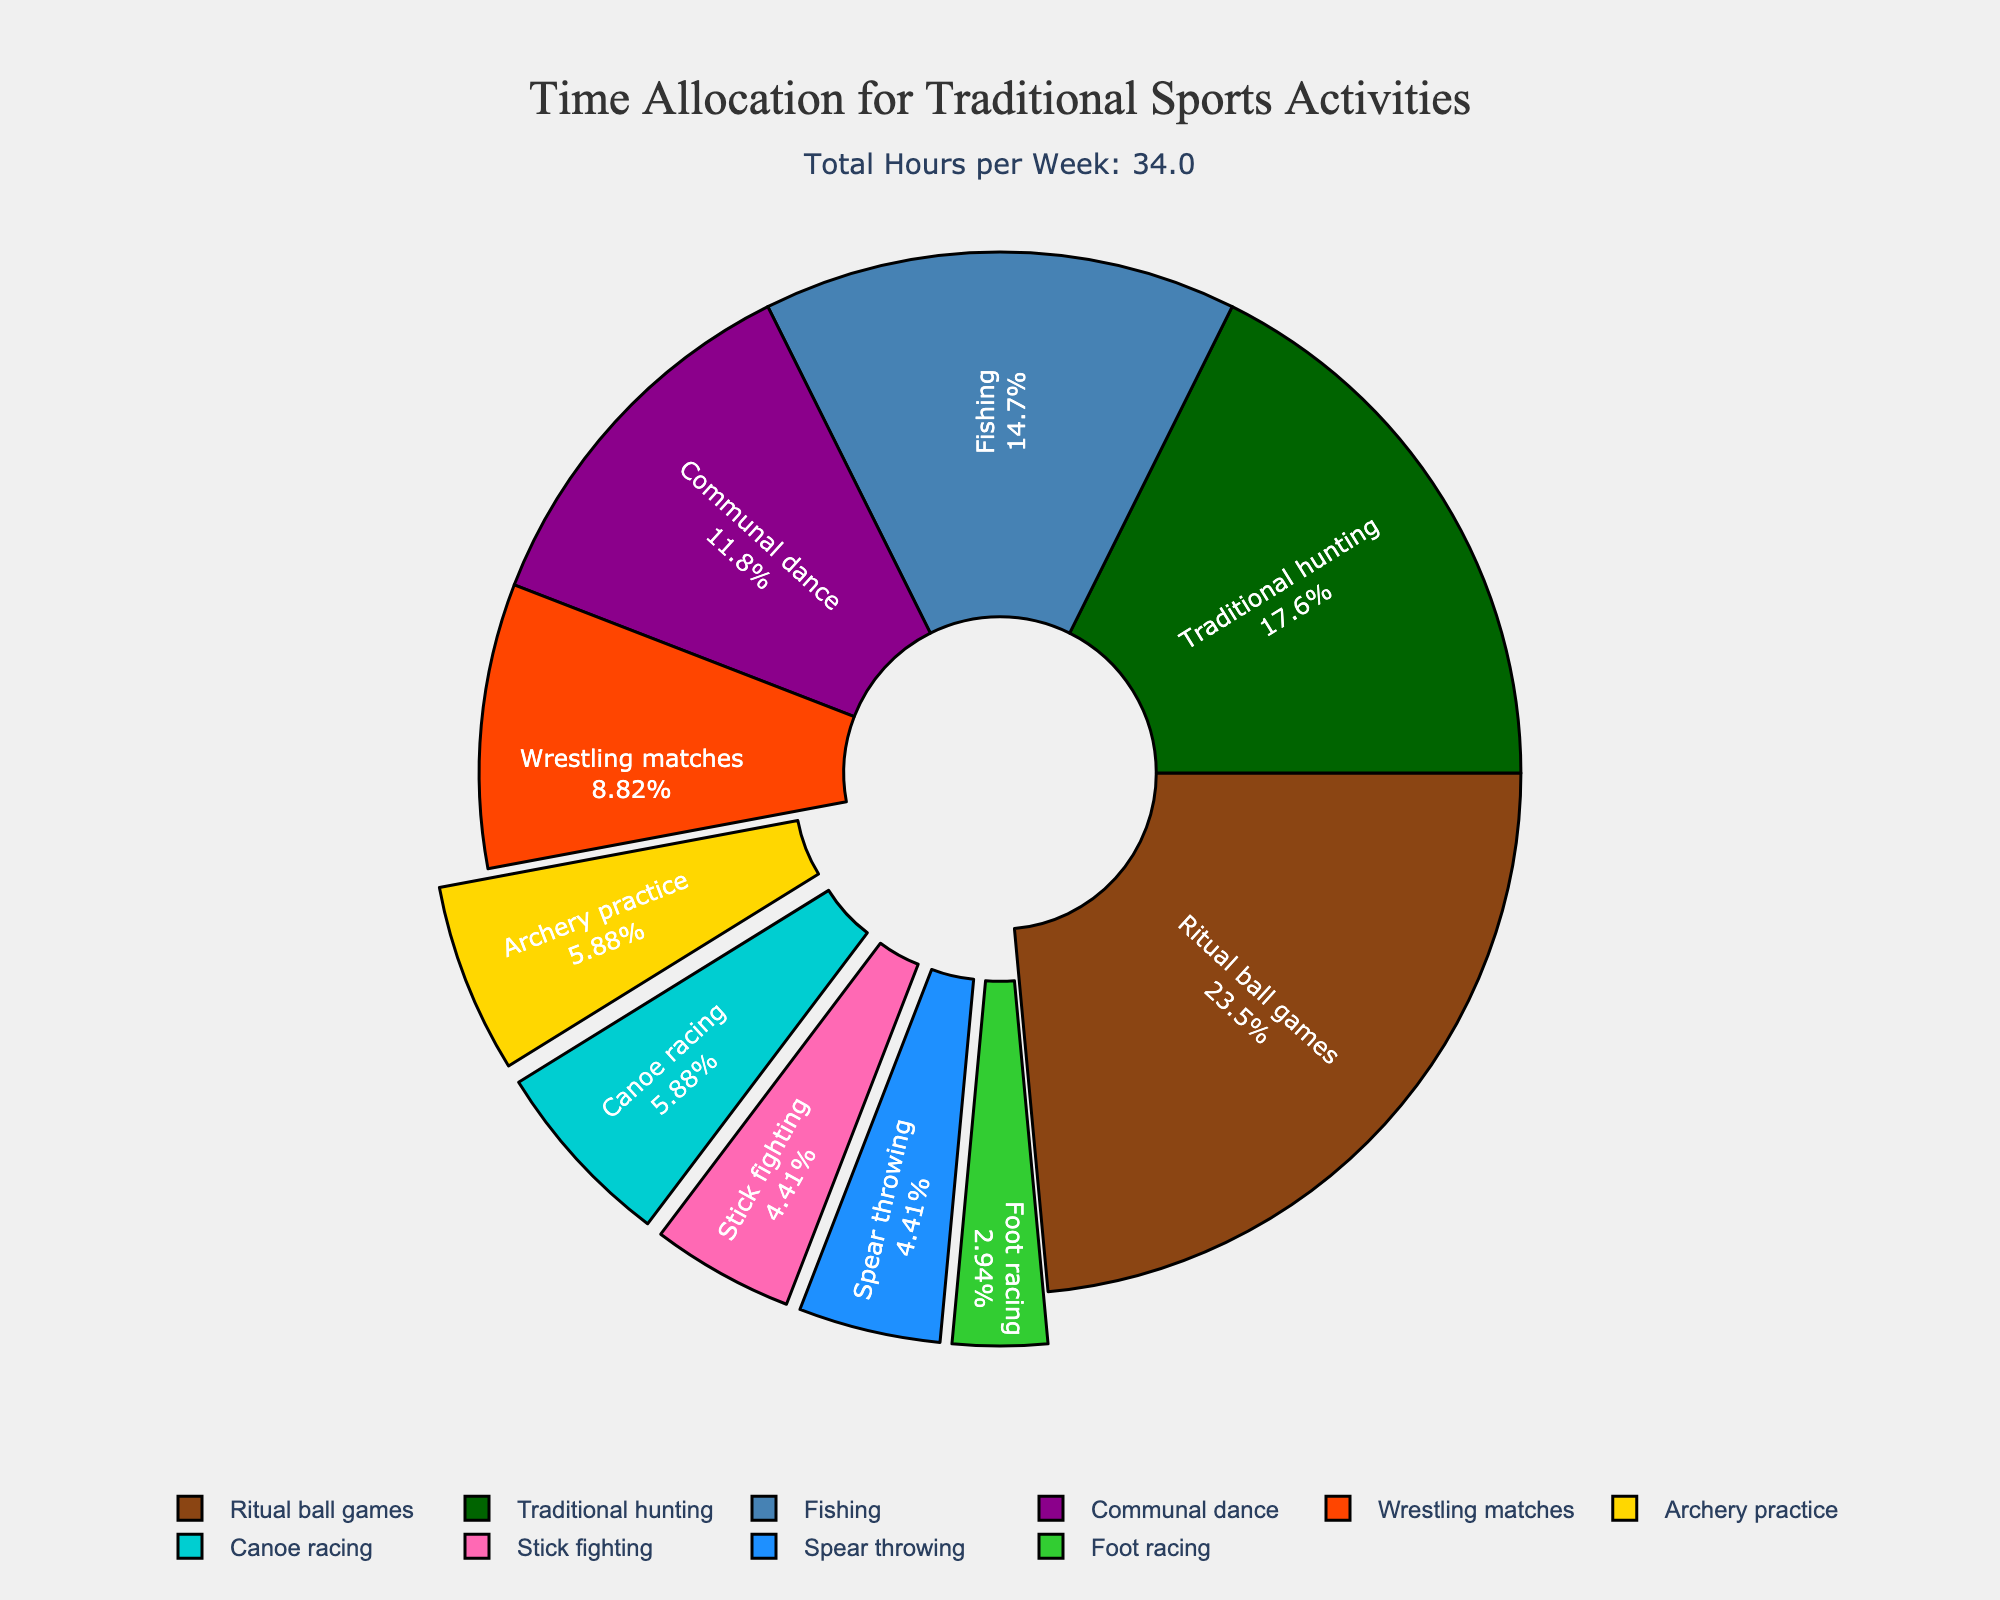What's the most time-intensive sport activity? By looking at the pie chart, we can see that the largest slice correlates with Ritual ball games, making it the most time-intensive sport activity with 8 hours per week.
Answer: Ritual ball games Which two activities have the smallest percentages of time allocation? The pie chart indicates that both Stick fighting and Spear throwing have the smallest slices, each corresponding to 1.5 hours per week.
Answer: Stick fighting and Spear throwing What percentage of total time is spent on Archery practice and Canoe racing combined? The pie chart shows that Archery practice accounts for 2 hours and Canoe racing also accounts for 2 hours. Summing these gives us 4 hours out of the total 33 hours per week. The combined percentage is (4/33) * 100 ≈ 12.12%.
Answer: 12.12% How does the time spent on Wrestling matches compare to that of Communal dance? From the pie chart, Wrestling matches account for 3 hours per week, and Communal dance accounts for 4 hours per week. Thus, more time is spent on Communal dance.
Answer: More time is spent on Communal dance What's the total time spent on activities with slices pulled out? Activities with slices pulled out have less than 3 hours per week allocated. Summing the hours: Archery practice (2), Canoe racing (2), Stick fighting (1.5), Spear throwing (1.5), and Foot racing (1) results in 8 hours per week.
Answer: 8 hours per week How many more hours per week are spent on Ritual ball games compared to Wrestling matches? The pie chart shows 8 hours for Ritual ball games and 3 hours for Wrestling matches. The difference is 8 - 3 = 5 hours.
Answer: 5 hours What's the total percentage of time dedicated to Traditional hunting and Fishing? The pie chart shows Traditional hunting at 6 hours per week and Fishing at 5 hours per week. Summing these gives us 11 hours out of the total 33 hours per week. The combined percentage is (11/33) * 100 ≈ 33.33%.
Answer: 33.33% Which activity is represented by the green slice in the pie chart? The pie chart uses a green color slice for Traditional hunting which accounts for 6 hours per week.
Answer: Traditional hunting 